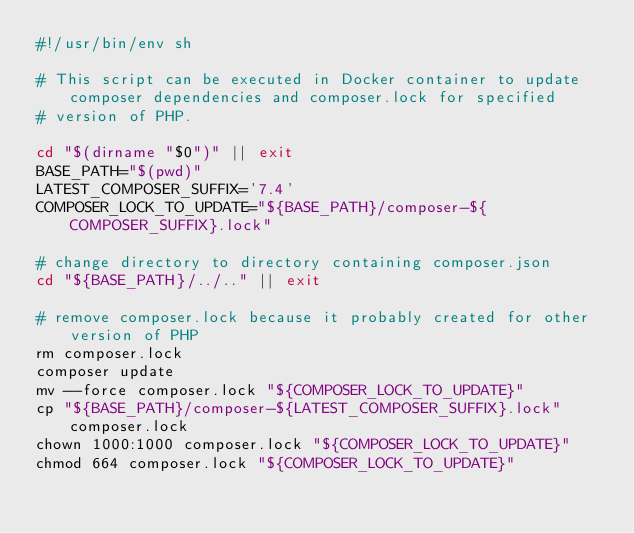<code> <loc_0><loc_0><loc_500><loc_500><_Bash_>#!/usr/bin/env sh

# This script can be executed in Docker container to update composer dependencies and composer.lock for specified
# version of PHP.

cd "$(dirname "$0")" || exit
BASE_PATH="$(pwd)"
LATEST_COMPOSER_SUFFIX='7.4'
COMPOSER_LOCK_TO_UPDATE="${BASE_PATH}/composer-${COMPOSER_SUFFIX}.lock"

# change directory to directory containing composer.json
cd "${BASE_PATH}/../.." || exit

# remove composer.lock because it probably created for other version of PHP
rm composer.lock
composer update
mv --force composer.lock "${COMPOSER_LOCK_TO_UPDATE}"
cp "${BASE_PATH}/composer-${LATEST_COMPOSER_SUFFIX}.lock" composer.lock
chown 1000:1000 composer.lock "${COMPOSER_LOCK_TO_UPDATE}"
chmod 664 composer.lock "${COMPOSER_LOCK_TO_UPDATE}"
</code> 